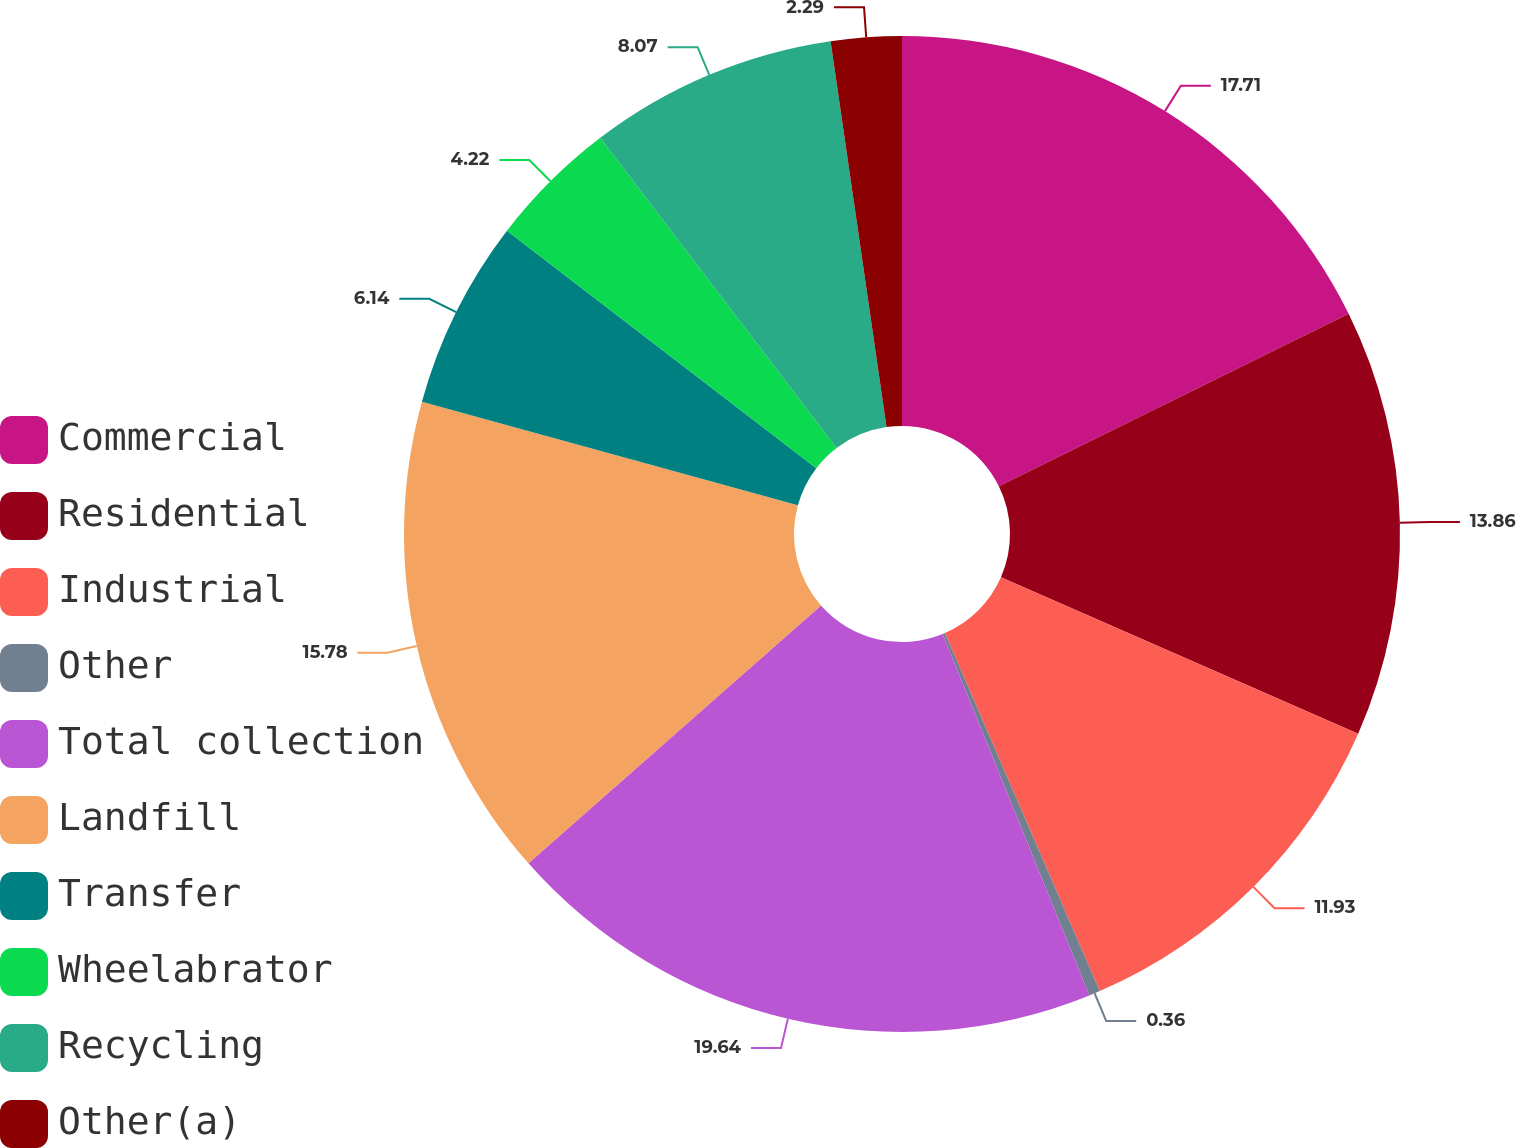<chart> <loc_0><loc_0><loc_500><loc_500><pie_chart><fcel>Commercial<fcel>Residential<fcel>Industrial<fcel>Other<fcel>Total collection<fcel>Landfill<fcel>Transfer<fcel>Wheelabrator<fcel>Recycling<fcel>Other(a)<nl><fcel>17.71%<fcel>13.86%<fcel>11.93%<fcel>0.36%<fcel>19.64%<fcel>15.78%<fcel>6.14%<fcel>4.22%<fcel>8.07%<fcel>2.29%<nl></chart> 